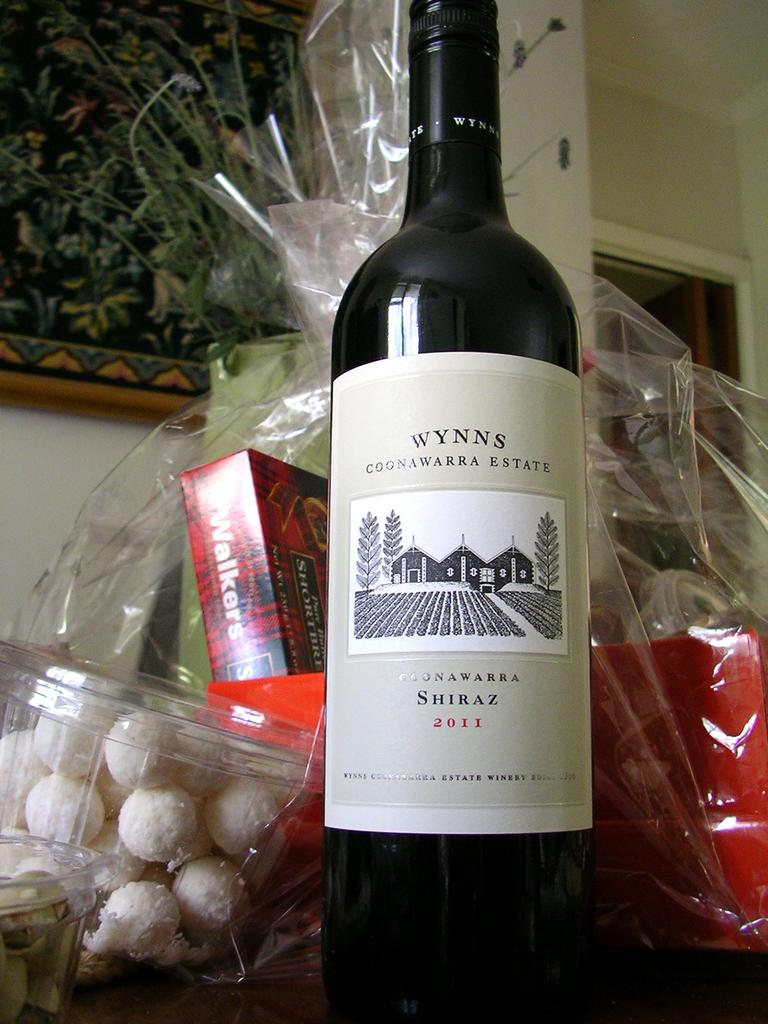Provide a one-sentence caption for the provided image. the word wynn's that is on a wine bottle. 